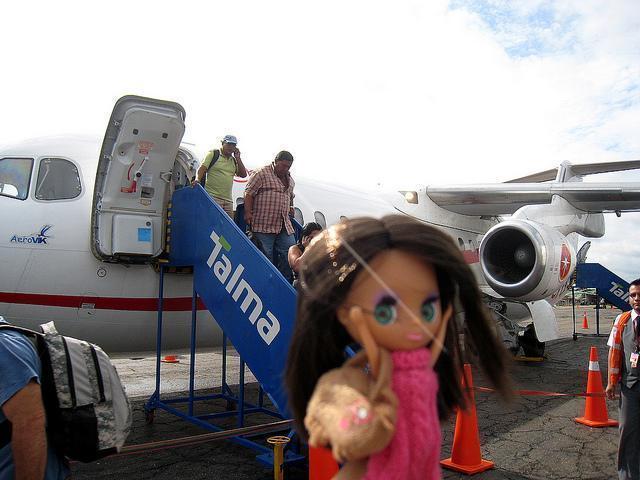What type of doll is in the front of the picture?
Answer the question by selecting the correct answer among the 4 following choices and explain your choice with a short sentence. The answer should be formatted with the following format: `Answer: choice
Rationale: rationale.`
Options: Barbie, beanie babies, bratz, elsa. Answer: bratz.
Rationale: The doll is a bratz. 